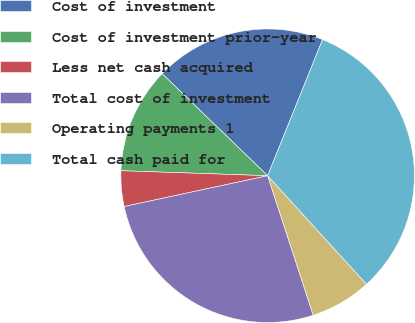<chart> <loc_0><loc_0><loc_500><loc_500><pie_chart><fcel>Cost of investment<fcel>Cost of investment prior-year<fcel>Less net cash acquired<fcel>Total cost of investment<fcel>Operating payments 1<fcel>Total cash paid for<nl><fcel>18.87%<fcel>11.69%<fcel>3.91%<fcel>26.66%<fcel>6.73%<fcel>32.14%<nl></chart> 